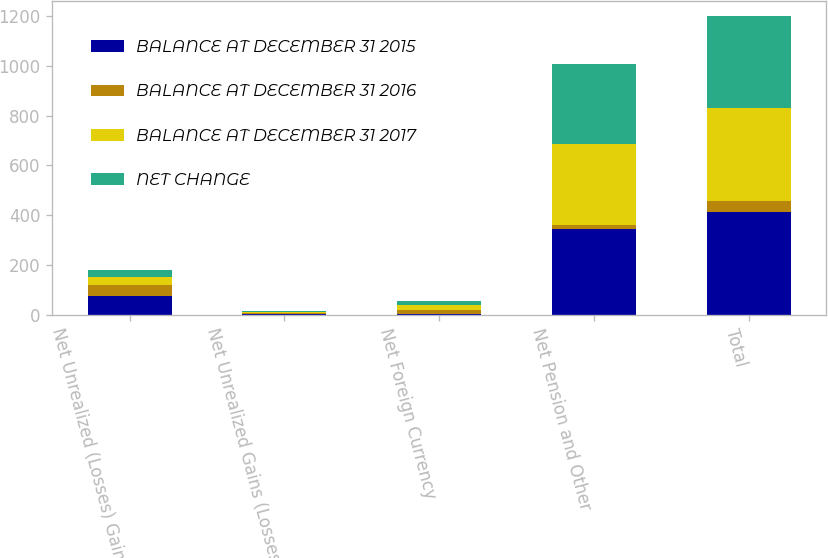<chart> <loc_0><loc_0><loc_500><loc_500><stacked_bar_chart><ecel><fcel>Net Unrealized (Losses) Gains<fcel>Net Unrealized Gains (Losses)<fcel>Net Foreign Currency<fcel>Net Pension and Other<fcel>Total<nl><fcel>BALANCE AT DECEMBER 31 2015<fcel>74.8<fcel>4.5<fcel>1.8<fcel>342.2<fcel>414.3<nl><fcel>BALANCE AT DECEMBER 31 2016<fcel>42.4<fcel>1.6<fcel>16.7<fcel>17<fcel>44.3<nl><fcel>BALANCE AT DECEMBER 31 2017<fcel>32.4<fcel>6.1<fcel>18.5<fcel>325.2<fcel>370<nl><fcel>NET CHANGE<fcel>31<fcel>3<fcel>17.6<fcel>321.1<fcel>372.7<nl></chart> 